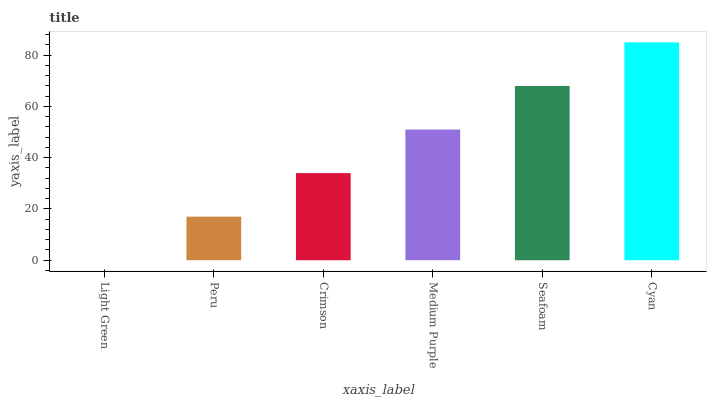Is Light Green the minimum?
Answer yes or no. Yes. Is Cyan the maximum?
Answer yes or no. Yes. Is Peru the minimum?
Answer yes or no. No. Is Peru the maximum?
Answer yes or no. No. Is Peru greater than Light Green?
Answer yes or no. Yes. Is Light Green less than Peru?
Answer yes or no. Yes. Is Light Green greater than Peru?
Answer yes or no. No. Is Peru less than Light Green?
Answer yes or no. No. Is Medium Purple the high median?
Answer yes or no. Yes. Is Crimson the low median?
Answer yes or no. Yes. Is Light Green the high median?
Answer yes or no. No. Is Seafoam the low median?
Answer yes or no. No. 